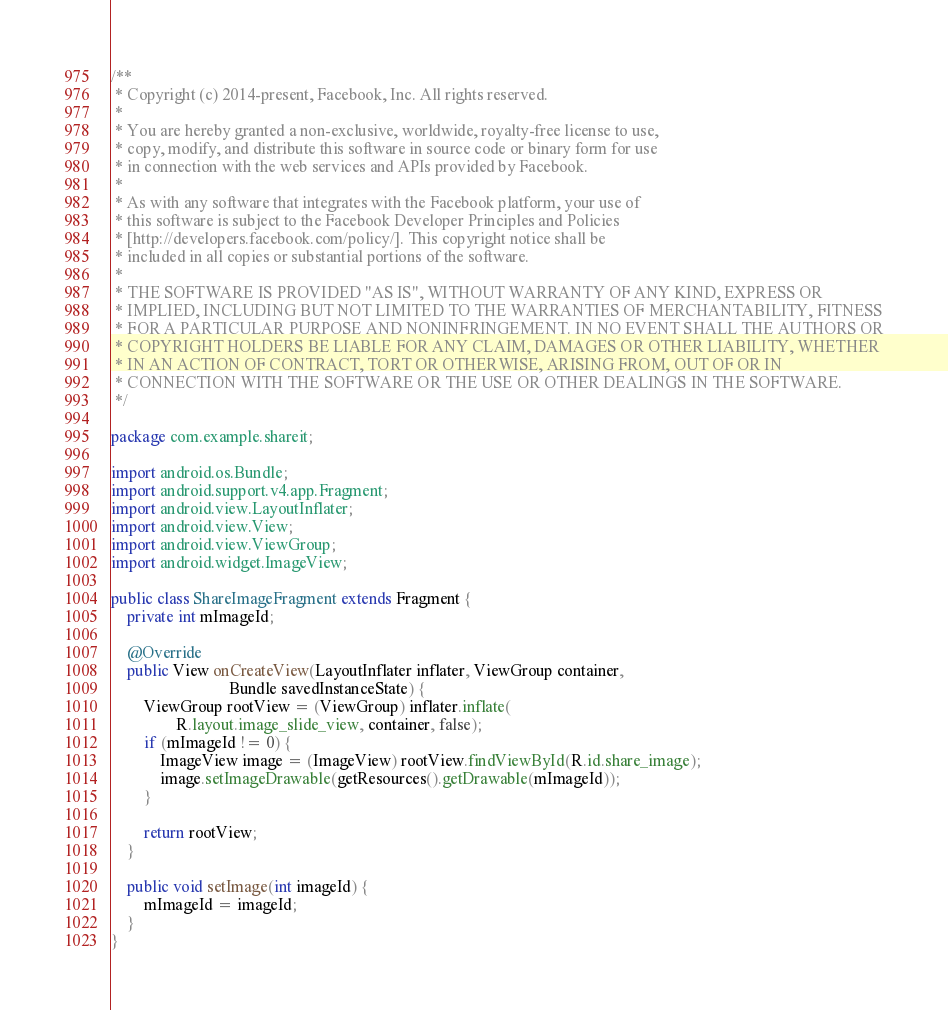<code> <loc_0><loc_0><loc_500><loc_500><_Java_>/**
 * Copyright (c) 2014-present, Facebook, Inc. All rights reserved.
 *
 * You are hereby granted a non-exclusive, worldwide, royalty-free license to use,
 * copy, modify, and distribute this software in source code or binary form for use
 * in connection with the web services and APIs provided by Facebook.
 *
 * As with any software that integrates with the Facebook platform, your use of
 * this software is subject to the Facebook Developer Principles and Policies
 * [http://developers.facebook.com/policy/]. This copyright notice shall be
 * included in all copies or substantial portions of the software.
 *
 * THE SOFTWARE IS PROVIDED "AS IS", WITHOUT WARRANTY OF ANY KIND, EXPRESS OR
 * IMPLIED, INCLUDING BUT NOT LIMITED TO THE WARRANTIES OF MERCHANTABILITY, FITNESS
 * FOR A PARTICULAR PURPOSE AND NONINFRINGEMENT. IN NO EVENT SHALL THE AUTHORS OR
 * COPYRIGHT HOLDERS BE LIABLE FOR ANY CLAIM, DAMAGES OR OTHER LIABILITY, WHETHER
 * IN AN ACTION OF CONTRACT, TORT OR OTHERWISE, ARISING FROM, OUT OF OR IN
 * CONNECTION WITH THE SOFTWARE OR THE USE OR OTHER DEALINGS IN THE SOFTWARE.
 */

package com.example.shareit;

import android.os.Bundle;
import android.support.v4.app.Fragment;
import android.view.LayoutInflater;
import android.view.View;
import android.view.ViewGroup;
import android.widget.ImageView;

public class ShareImageFragment extends Fragment {
    private int mImageId;

    @Override
    public View onCreateView(LayoutInflater inflater, ViewGroup container,
                             Bundle savedInstanceState) {
        ViewGroup rootView = (ViewGroup) inflater.inflate(
                R.layout.image_slide_view, container, false);
        if (mImageId != 0) {
            ImageView image = (ImageView) rootView.findViewById(R.id.share_image);
            image.setImageDrawable(getResources().getDrawable(mImageId));
        }

        return rootView;
    }

    public void setImage(int imageId) {
        mImageId = imageId;
    }
}
</code> 